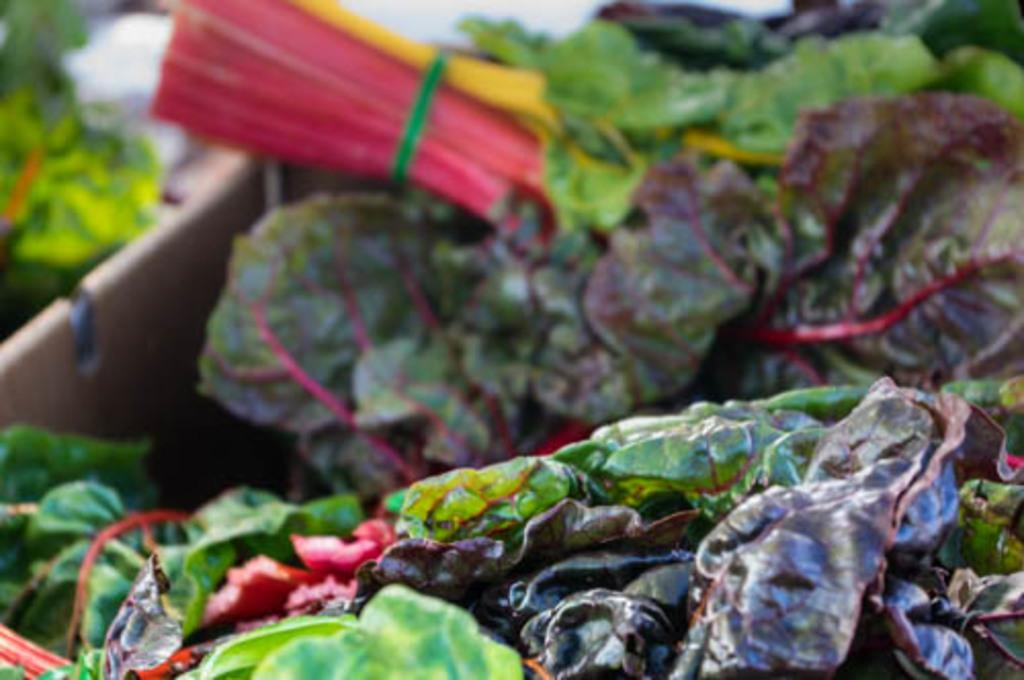What type of vegetation can be seen in the image? There are leaves in the image. Can you describe the background of the image? The background of the image is blurred. What type of rock is the boy holding in the image? There is no rock or boy present in the image; it only features leaves and a blurred background. 